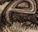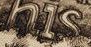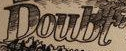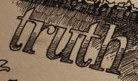What words are shown in these images in order, separated by a semicolon? e; his; Doubt; truth 